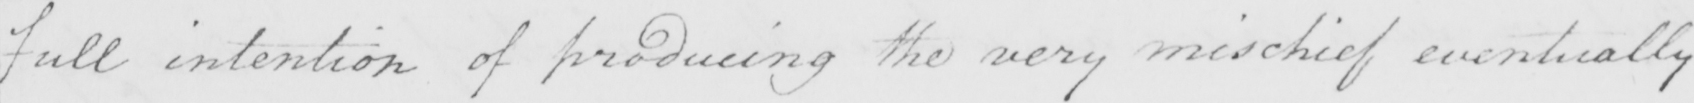Please transcribe the handwritten text in this image. full intention of producing the very mischief eventually 